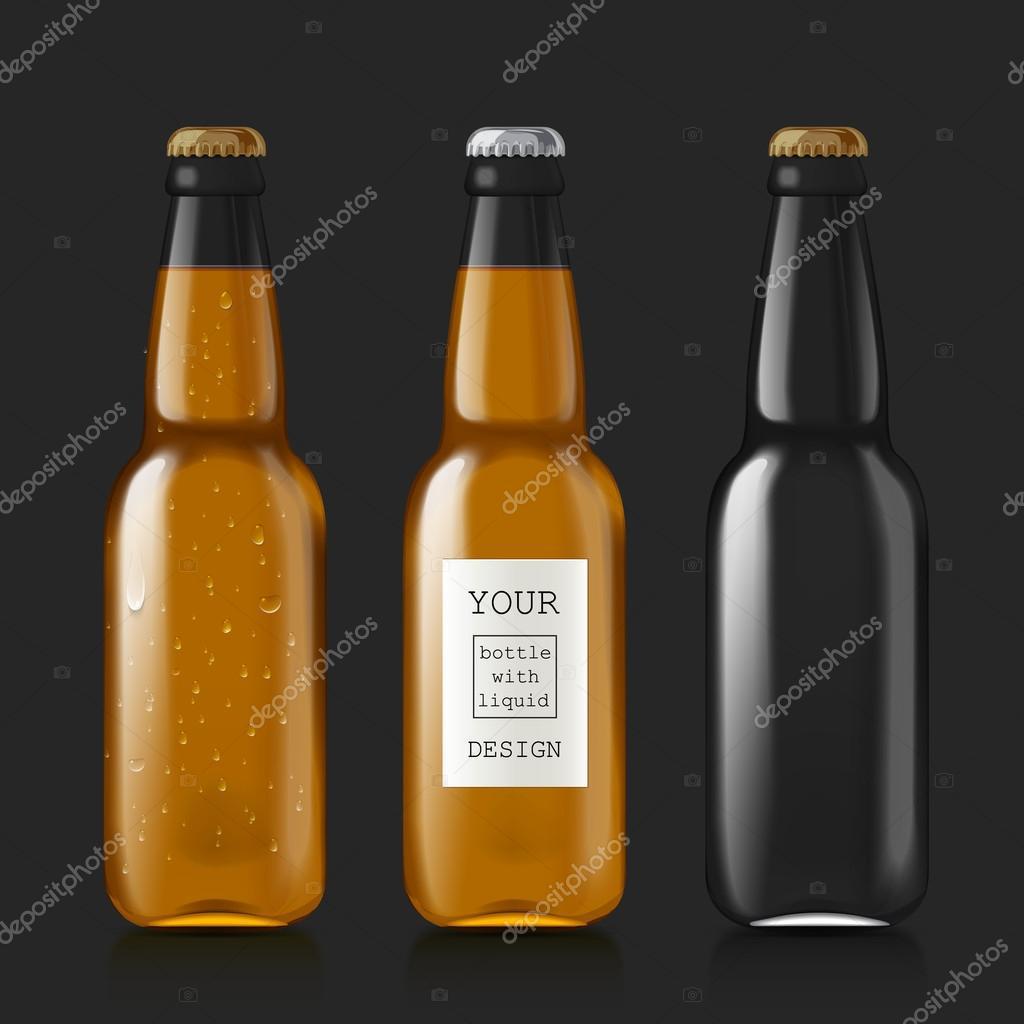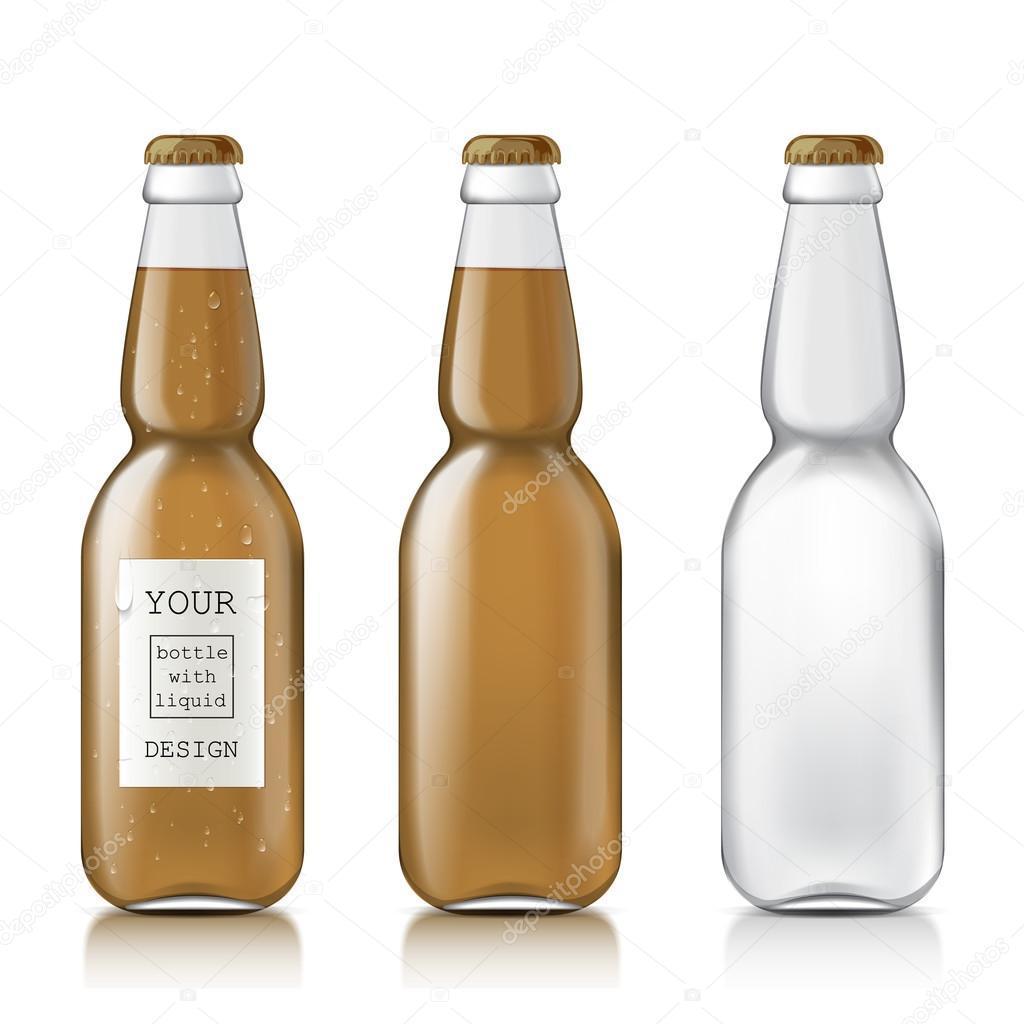The first image is the image on the left, the second image is the image on the right. Considering the images on both sides, is "Each image contains exactly three bottles." valid? Answer yes or no. Yes. The first image is the image on the left, the second image is the image on the right. Given the left and right images, does the statement "At least eight bottles of beer are shown." hold true? Answer yes or no. No. 